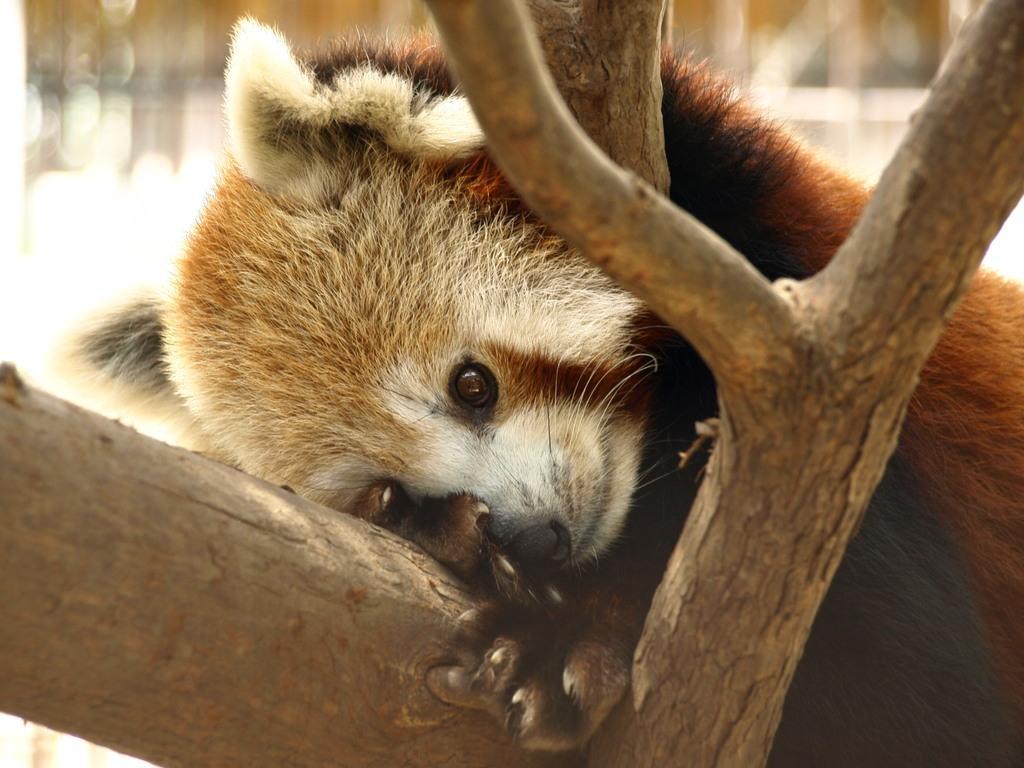Could you give a brief overview of what you see in this image? In this image, we can see an animal on tree. In the background, image is blurred. 